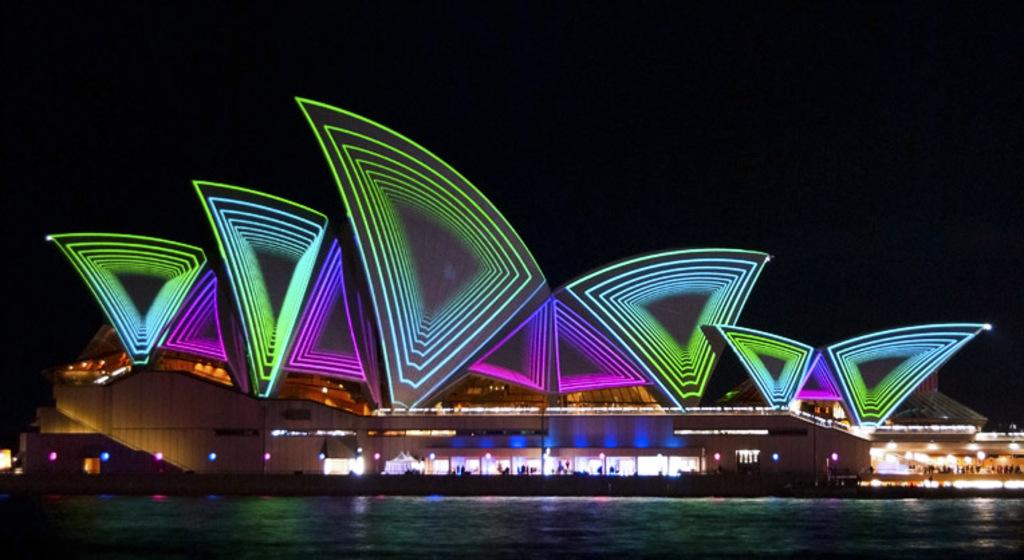What type of structure is present in the image? There is a building in the image. What natural feature can be seen in the image? There is a lake in the image. What is visible in the background of the image? The sky is visible in the image. What is the source of illumination in the image? There are many lights in the image. Can you describe the activity taking place inside the building? There are many people inside the building. What type of cart is being used by the authority to transport the brain in the image? There is no cart, authority, or brain present in the image. 